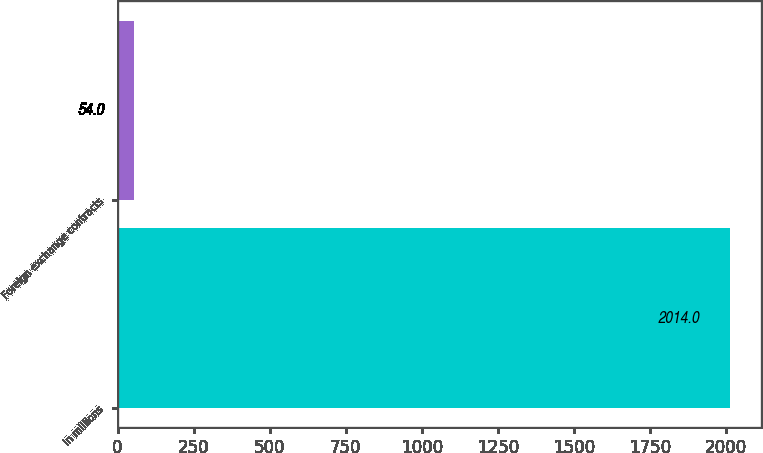Convert chart. <chart><loc_0><loc_0><loc_500><loc_500><bar_chart><fcel>In millions<fcel>Foreign exchange contracts<nl><fcel>2014<fcel>54<nl></chart> 